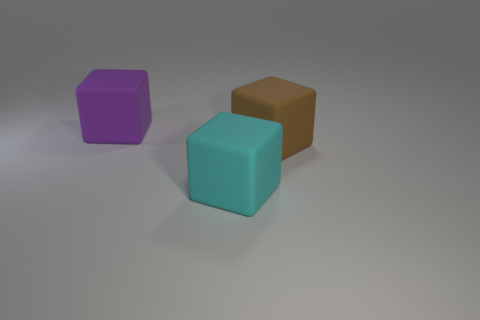What number of other things are the same size as the cyan matte object?
Your response must be concise. 2. What number of things are brown rubber cubes in front of the purple cube or big brown rubber cubes behind the cyan object?
Keep it short and to the point. 1. What shape is the brown matte thing that is the same size as the cyan rubber block?
Your answer should be compact. Cube. What size is the cyan cube that is made of the same material as the purple object?
Make the answer very short. Large. There is a brown rubber thing that is the same shape as the cyan object; what size is it?
Your response must be concise. Large. What shape is the large thing in front of the big brown matte block?
Provide a succinct answer. Cube. There is a cyan matte object; is its shape the same as the thing that is left of the large cyan rubber cube?
Make the answer very short. Yes. Are there an equal number of large matte objects that are in front of the large purple cube and matte blocks that are behind the big brown matte block?
Keep it short and to the point. No. Is the color of the large object behind the large brown object the same as the big block in front of the brown block?
Ensure brevity in your answer.  No. Are there more things that are in front of the purple rubber thing than big cyan cubes?
Provide a succinct answer. Yes. 